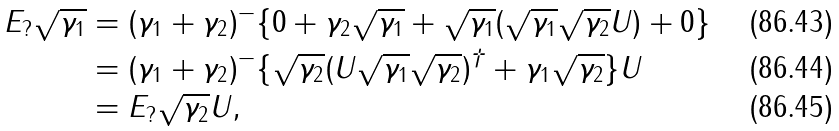<formula> <loc_0><loc_0><loc_500><loc_500>E _ { ? } \sqrt { \gamma _ { 1 } } & = ( \gamma _ { 1 } + \gamma _ { 2 } ) ^ { - } \{ 0 + \gamma _ { 2 } \sqrt { \gamma _ { 1 } } + \sqrt { \gamma _ { 1 } } ( \sqrt { \gamma _ { 1 } } \sqrt { \gamma _ { 2 } } U ) + 0 \} \\ & = ( \gamma _ { 1 } + \gamma _ { 2 } ) ^ { - } \{ \sqrt { \gamma _ { 2 } } ( U \sqrt { \gamma _ { 1 } } \sqrt { \gamma _ { 2 } } ) ^ { \dag } + \gamma _ { 1 } \sqrt { \gamma _ { 2 } } \} U \\ & = E _ { ? } \sqrt { \gamma _ { 2 } } U ,</formula> 